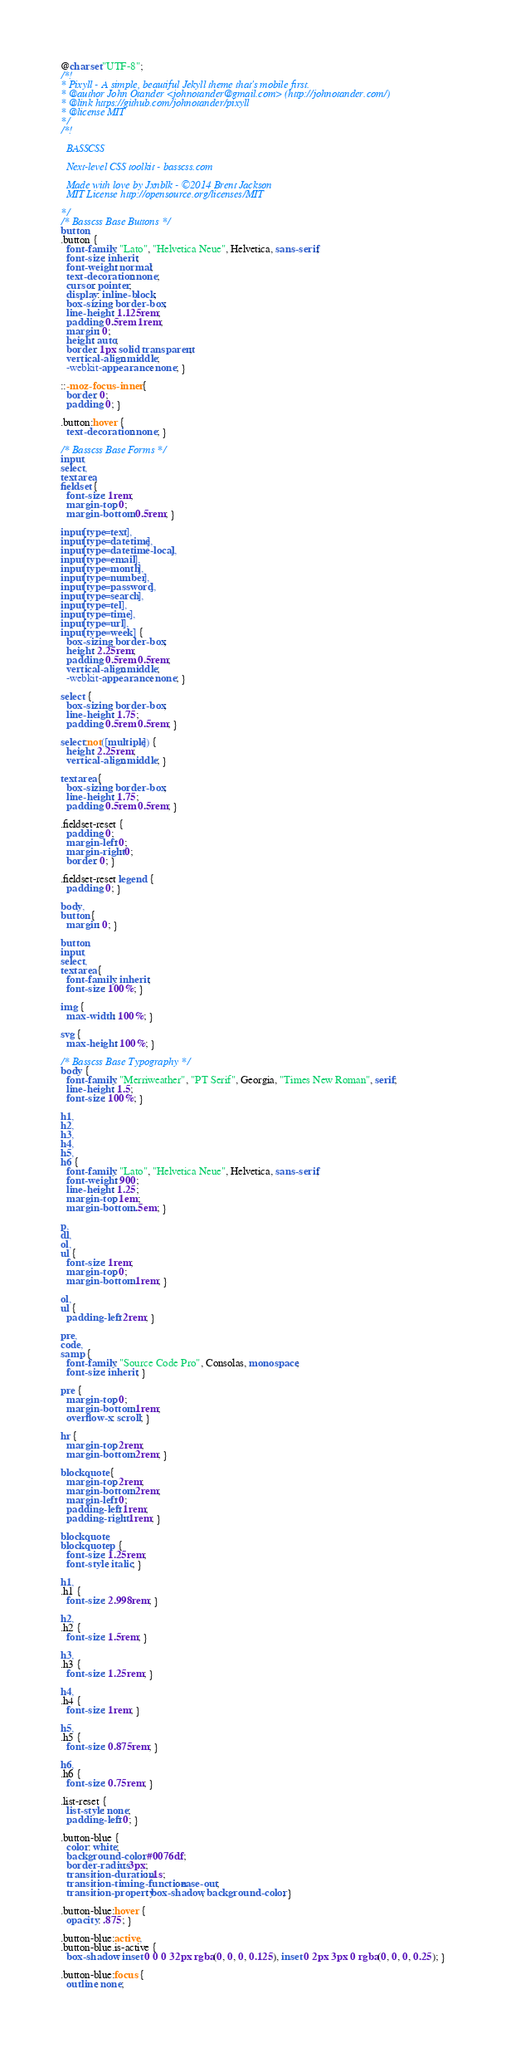Convert code to text. <code><loc_0><loc_0><loc_500><loc_500><_CSS_>@charset "UTF-8";
/*!
* Pixyll - A simple, beautiful Jekyll theme that's mobile first.
* @author John Otander <johnotander@gmail.com> (http://johnotander.com/)
* @link https://github.com/johnotander/pixyll
* @license MIT
*/
/*!

  BASSCSS

  Next-level CSS toolkit - basscss.com

  Made with love by Jxnblk - ©2014 Brent Jackson
  MIT License http://opensource.org/licenses/MIT

*/
/* Basscss Base Buttons */
button,
.button {
  font-family: "Lato", "Helvetica Neue", Helvetica, sans-serif;
  font-size: inherit;
  font-weight: normal;
  text-decoration: none;
  cursor: pointer;
  display: inline-block;
  box-sizing: border-box;
  line-height: 1.125rem;
  padding: 0.5rem 1rem;
  margin: 0;
  height: auto;
  border: 1px solid transparent;
  vertical-align: middle;
  -webkit-appearance: none; }

::-moz-focus-inner {
  border: 0;
  padding: 0; }

.button:hover {
  text-decoration: none; }

/* Basscss Base Forms */
input,
select,
textarea,
fieldset {
  font-size: 1rem;
  margin-top: 0;
  margin-bottom: 0.5rem; }

input[type=text],
input[type=datetime],
input[type=datetime-local],
input[type=email],
input[type=month],
input[type=number],
input[type=password],
input[type=search],
input[type=tel],
input[type=time],
input[type=url],
input[type=week] {
  box-sizing: border-box;
  height: 2.25rem;
  padding: 0.5rem 0.5rem;
  vertical-align: middle;
  -webkit-appearance: none; }

select {
  box-sizing: border-box;
  line-height: 1.75;
  padding: 0.5rem 0.5rem; }

select:not([multiple]) {
  height: 2.25rem;
  vertical-align: middle; }

textarea {
  box-sizing: border-box;
  line-height: 1.75;
  padding: 0.5rem 0.5rem; }

.fieldset-reset {
  padding: 0;
  margin-left: 0;
  margin-right: 0;
  border: 0; }

.fieldset-reset legend {
  padding: 0; }

body,
button {
  margin: 0; }

button,
input,
select,
textarea {
  font-family: inherit;
  font-size: 100%; }

img {
  max-width: 100%; }

svg {
  max-height: 100%; }

/* Basscss Base Typography */
body {
  font-family: "Merriweather", "PT Serif", Georgia, "Times New Roman", serif;
  line-height: 1.5;
  font-size: 100%; }

h1,
h2,
h3,
h4,
h5,
h6 {
  font-family: "Lato", "Helvetica Neue", Helvetica, sans-serif;
  font-weight: 900;
  line-height: 1.25;
  margin-top: 1em;
  margin-bottom: .5em; }

p,
dl,
ol,
ul {
  font-size: 1rem;
  margin-top: 0;
  margin-bottom: 1rem; }

ol,
ul {
  padding-left: 2rem; }

pre,
code,
samp {
  font-family: "Source Code Pro", Consolas, monospace;
  font-size: inherit; }

pre {
  margin-top: 0;
  margin-bottom: 1rem;
  overflow-x: scroll; }

hr {
  margin-top: 2rem;
  margin-bottom: 2rem; }

blockquote {
  margin-top: 2rem;
  margin-bottom: 2rem;
  margin-left: 0;
  padding-left: 1rem;
  padding-right: 1rem; }

blockquote,
blockquote p {
  font-size: 1.25rem;
  font-style: italic; }

h1,
.h1 {
  font-size: 2.998rem; }

h2,
.h2 {
  font-size: 1.5rem; }

h3,
.h3 {
  font-size: 1.25rem; }

h4,
.h4 {
  font-size: 1rem; }

h5,
.h5 {
  font-size: 0.875rem; }

h6,
.h6 {
  font-size: 0.75rem; }

.list-reset {
  list-style: none;
  padding-left: 0; }

.button-blue {
  color: white;
  background-color: #0076df;
  border-radius: 3px;
  transition-duration: .1s;
  transition-timing-function: ease-out;
  transition-property: box-shadow, background-color; }

.button-blue:hover {
  opacity: .875; }

.button-blue:active,
.button-blue.is-active {
  box-shadow: inset 0 0 0 32px rgba(0, 0, 0, 0.125), inset 0 2px 3px 0 rgba(0, 0, 0, 0.25); }

.button-blue:focus {
  outline: none;</code> 